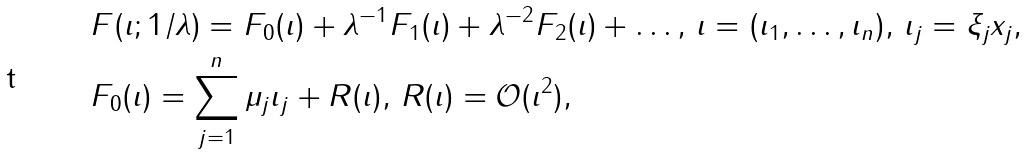Convert formula to latex. <formula><loc_0><loc_0><loc_500><loc_500>& F ( \imath ; 1 / \lambda ) = F _ { 0 } ( \imath ) + \lambda ^ { - 1 } F _ { 1 } ( \imath ) + \lambda ^ { - 2 } F _ { 2 } ( \imath ) + \dots , \, \imath = ( \imath _ { 1 } , \dots , \imath _ { n } ) , \, \imath _ { j } = \xi _ { j } x _ { j } , \\ & F _ { 0 } ( \imath ) = \sum _ { j = 1 } ^ { n } \mu _ { j } \imath _ { j } + R ( \imath ) , \, R ( \imath ) = { \mathcal { O } } ( \imath ^ { 2 } ) ,</formula> 